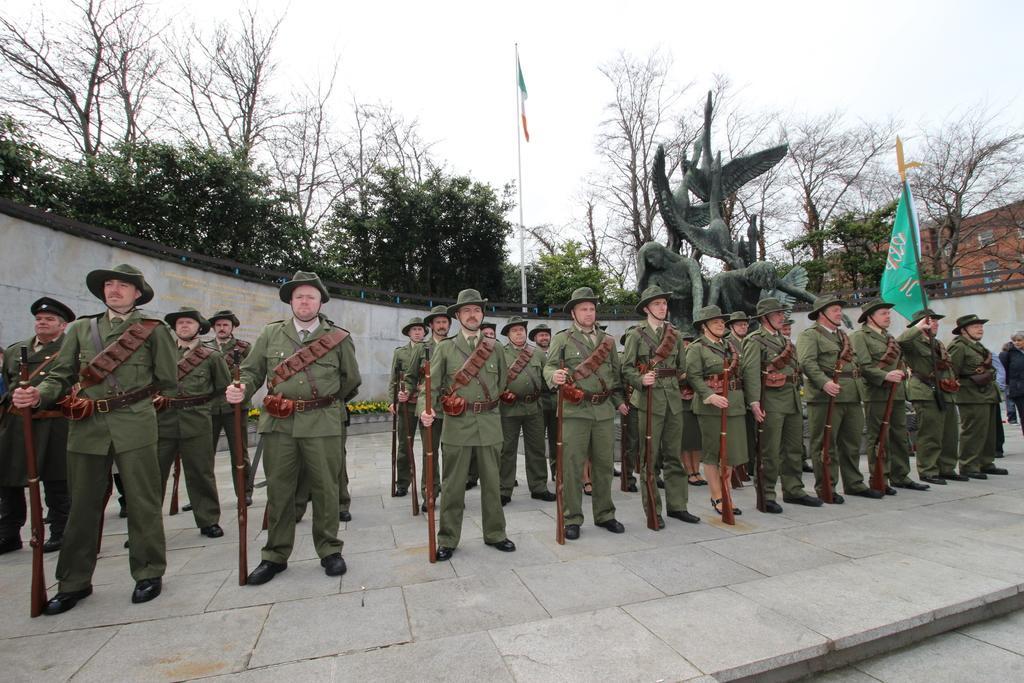Please provide a concise description of this image. In this image we can see group of persons wearing army dress holding guns in their hands and in the background of the image there is a sculpture, there are some flags, wall, there are some trees and top of the image there is clear sky. 